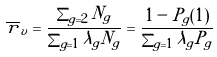<formula> <loc_0><loc_0><loc_500><loc_500>\overline { r } _ { v } = \frac { \sum _ { g = 2 } N _ { g } } { \sum _ { g = 1 } \lambda _ { g } N _ { g } } = \frac { 1 - P _ { g } ( 1 ) } { \sum _ { g = 1 } \lambda _ { g } P _ { g } }</formula> 